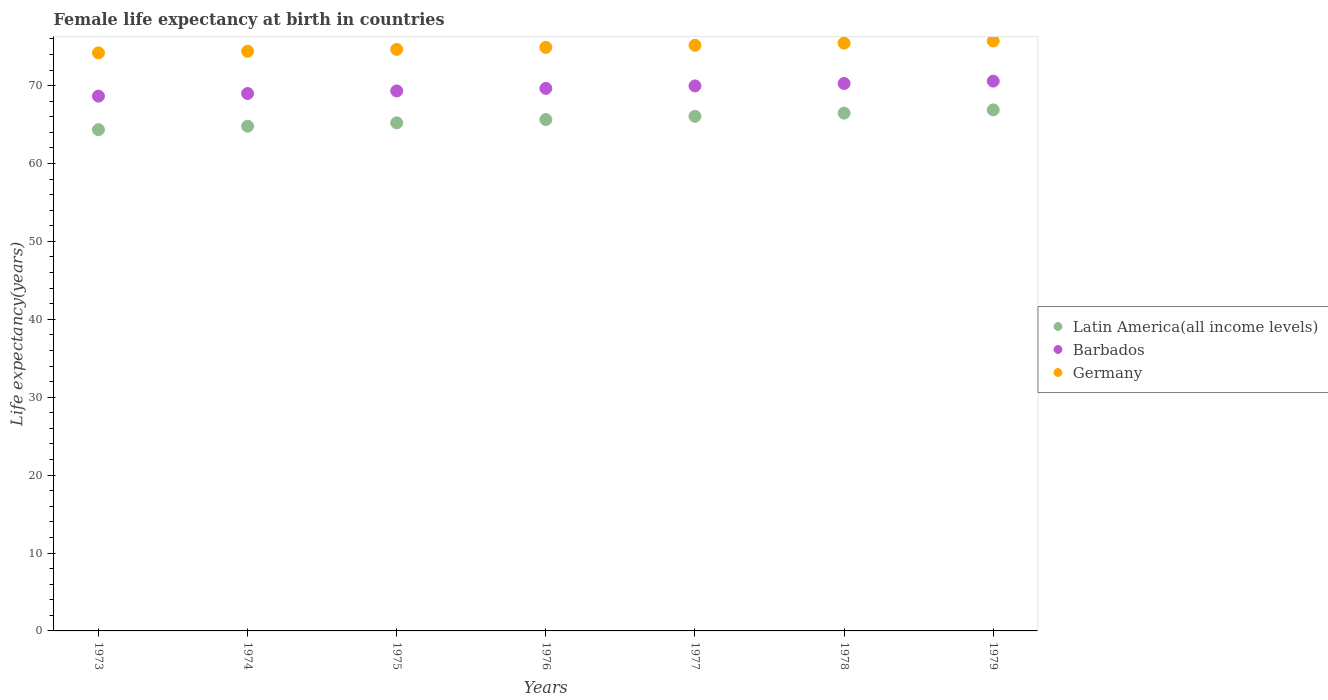What is the female life expectancy at birth in Latin America(all income levels) in 1977?
Your answer should be compact. 66.05. Across all years, what is the maximum female life expectancy at birth in Germany?
Provide a short and direct response. 75.72. Across all years, what is the minimum female life expectancy at birth in Latin America(all income levels)?
Provide a short and direct response. 64.34. In which year was the female life expectancy at birth in Barbados maximum?
Provide a succinct answer. 1979. In which year was the female life expectancy at birth in Germany minimum?
Ensure brevity in your answer.  1973. What is the total female life expectancy at birth in Barbados in the graph?
Ensure brevity in your answer.  487.4. What is the difference between the female life expectancy at birth in Latin America(all income levels) in 1976 and that in 1978?
Provide a short and direct response. -0.83. What is the difference between the female life expectancy at birth in Germany in 1978 and the female life expectancy at birth in Latin America(all income levels) in 1976?
Your answer should be compact. 9.81. What is the average female life expectancy at birth in Germany per year?
Your answer should be compact. 74.93. In the year 1973, what is the difference between the female life expectancy at birth in Germany and female life expectancy at birth in Latin America(all income levels)?
Keep it short and to the point. 9.86. What is the ratio of the female life expectancy at birth in Germany in 1977 to that in 1979?
Your response must be concise. 0.99. What is the difference between the highest and the second highest female life expectancy at birth in Barbados?
Your answer should be compact. 0.3. What is the difference between the highest and the lowest female life expectancy at birth in Barbados?
Offer a terse response. 1.92. Is the sum of the female life expectancy at birth in Barbados in 1974 and 1975 greater than the maximum female life expectancy at birth in Germany across all years?
Provide a succinct answer. Yes. Is it the case that in every year, the sum of the female life expectancy at birth in Germany and female life expectancy at birth in Barbados  is greater than the female life expectancy at birth in Latin America(all income levels)?
Ensure brevity in your answer.  Yes. Is the female life expectancy at birth in Germany strictly less than the female life expectancy at birth in Latin America(all income levels) over the years?
Give a very brief answer. No. What is the difference between two consecutive major ticks on the Y-axis?
Give a very brief answer. 10. Are the values on the major ticks of Y-axis written in scientific E-notation?
Your answer should be compact. No. Does the graph contain any zero values?
Provide a succinct answer. No. Does the graph contain grids?
Your answer should be very brief. No. How are the legend labels stacked?
Ensure brevity in your answer.  Vertical. What is the title of the graph?
Keep it short and to the point. Female life expectancy at birth in countries. What is the label or title of the Y-axis?
Your answer should be compact. Life expectancy(years). What is the Life expectancy(years) of Latin America(all income levels) in 1973?
Give a very brief answer. 64.34. What is the Life expectancy(years) of Barbados in 1973?
Provide a short and direct response. 68.65. What is the Life expectancy(years) of Germany in 1973?
Ensure brevity in your answer.  74.2. What is the Life expectancy(years) in Latin America(all income levels) in 1974?
Give a very brief answer. 64.79. What is the Life expectancy(years) in Barbados in 1974?
Provide a succinct answer. 68.99. What is the Life expectancy(years) in Germany in 1974?
Your answer should be very brief. 74.41. What is the Life expectancy(years) in Latin America(all income levels) in 1975?
Ensure brevity in your answer.  65.22. What is the Life expectancy(years) of Barbados in 1975?
Provide a succinct answer. 69.32. What is the Life expectancy(years) of Germany in 1975?
Your answer should be compact. 74.65. What is the Life expectancy(years) of Latin America(all income levels) in 1976?
Keep it short and to the point. 65.64. What is the Life expectancy(years) in Barbados in 1976?
Make the answer very short. 69.64. What is the Life expectancy(years) of Germany in 1976?
Ensure brevity in your answer.  74.9. What is the Life expectancy(years) in Latin America(all income levels) in 1977?
Your response must be concise. 66.05. What is the Life expectancy(years) in Barbados in 1977?
Your answer should be very brief. 69.96. What is the Life expectancy(years) of Germany in 1977?
Provide a succinct answer. 75.17. What is the Life expectancy(years) in Latin America(all income levels) in 1978?
Provide a short and direct response. 66.47. What is the Life expectancy(years) of Barbados in 1978?
Make the answer very short. 70.27. What is the Life expectancy(years) of Germany in 1978?
Your response must be concise. 75.45. What is the Life expectancy(years) of Latin America(all income levels) in 1979?
Your answer should be very brief. 66.89. What is the Life expectancy(years) of Barbados in 1979?
Keep it short and to the point. 70.58. What is the Life expectancy(years) in Germany in 1979?
Offer a very short reply. 75.72. Across all years, what is the maximum Life expectancy(years) of Latin America(all income levels)?
Ensure brevity in your answer.  66.89. Across all years, what is the maximum Life expectancy(years) of Barbados?
Keep it short and to the point. 70.58. Across all years, what is the maximum Life expectancy(years) in Germany?
Give a very brief answer. 75.72. Across all years, what is the minimum Life expectancy(years) in Latin America(all income levels)?
Your response must be concise. 64.34. Across all years, what is the minimum Life expectancy(years) in Barbados?
Provide a succinct answer. 68.65. Across all years, what is the minimum Life expectancy(years) of Germany?
Make the answer very short. 74.2. What is the total Life expectancy(years) in Latin America(all income levels) in the graph?
Your response must be concise. 459.4. What is the total Life expectancy(years) of Barbados in the graph?
Your answer should be compact. 487.4. What is the total Life expectancy(years) of Germany in the graph?
Your answer should be compact. 524.51. What is the difference between the Life expectancy(years) of Latin America(all income levels) in 1973 and that in 1974?
Make the answer very short. -0.45. What is the difference between the Life expectancy(years) in Barbados in 1973 and that in 1974?
Keep it short and to the point. -0.34. What is the difference between the Life expectancy(years) in Germany in 1973 and that in 1974?
Make the answer very short. -0.21. What is the difference between the Life expectancy(years) of Latin America(all income levels) in 1973 and that in 1975?
Your answer should be compact. -0.88. What is the difference between the Life expectancy(years) of Barbados in 1973 and that in 1975?
Keep it short and to the point. -0.67. What is the difference between the Life expectancy(years) in Germany in 1973 and that in 1975?
Offer a very short reply. -0.45. What is the difference between the Life expectancy(years) of Latin America(all income levels) in 1973 and that in 1976?
Provide a short and direct response. -1.3. What is the difference between the Life expectancy(years) of Barbados in 1973 and that in 1976?
Ensure brevity in your answer.  -0.99. What is the difference between the Life expectancy(years) of Germany in 1973 and that in 1976?
Give a very brief answer. -0.7. What is the difference between the Life expectancy(years) of Latin America(all income levels) in 1973 and that in 1977?
Give a very brief answer. -1.71. What is the difference between the Life expectancy(years) of Barbados in 1973 and that in 1977?
Keep it short and to the point. -1.31. What is the difference between the Life expectancy(years) of Germany in 1973 and that in 1977?
Provide a succinct answer. -0.97. What is the difference between the Life expectancy(years) of Latin America(all income levels) in 1973 and that in 1978?
Ensure brevity in your answer.  -2.13. What is the difference between the Life expectancy(years) of Barbados in 1973 and that in 1978?
Provide a short and direct response. -1.62. What is the difference between the Life expectancy(years) of Germany in 1973 and that in 1978?
Give a very brief answer. -1.25. What is the difference between the Life expectancy(years) of Latin America(all income levels) in 1973 and that in 1979?
Make the answer very short. -2.54. What is the difference between the Life expectancy(years) of Barbados in 1973 and that in 1979?
Offer a very short reply. -1.92. What is the difference between the Life expectancy(years) of Germany in 1973 and that in 1979?
Your response must be concise. -1.52. What is the difference between the Life expectancy(years) in Latin America(all income levels) in 1974 and that in 1975?
Give a very brief answer. -0.43. What is the difference between the Life expectancy(years) in Barbados in 1974 and that in 1975?
Ensure brevity in your answer.  -0.33. What is the difference between the Life expectancy(years) of Germany in 1974 and that in 1975?
Offer a terse response. -0.23. What is the difference between the Life expectancy(years) in Latin America(all income levels) in 1974 and that in 1976?
Your answer should be very brief. -0.85. What is the difference between the Life expectancy(years) in Barbados in 1974 and that in 1976?
Provide a succinct answer. -0.66. What is the difference between the Life expectancy(years) of Germany in 1974 and that in 1976?
Keep it short and to the point. -0.49. What is the difference between the Life expectancy(years) of Latin America(all income levels) in 1974 and that in 1977?
Your answer should be very brief. -1.27. What is the difference between the Life expectancy(years) in Barbados in 1974 and that in 1977?
Give a very brief answer. -0.97. What is the difference between the Life expectancy(years) in Germany in 1974 and that in 1977?
Your answer should be compact. -0.76. What is the difference between the Life expectancy(years) of Latin America(all income levels) in 1974 and that in 1978?
Give a very brief answer. -1.68. What is the difference between the Life expectancy(years) in Barbados in 1974 and that in 1978?
Your answer should be compact. -1.28. What is the difference between the Life expectancy(years) in Germany in 1974 and that in 1978?
Your answer should be compact. -1.04. What is the difference between the Life expectancy(years) in Latin America(all income levels) in 1974 and that in 1979?
Provide a succinct answer. -2.1. What is the difference between the Life expectancy(years) in Barbados in 1974 and that in 1979?
Keep it short and to the point. -1.59. What is the difference between the Life expectancy(years) of Germany in 1974 and that in 1979?
Offer a very short reply. -1.31. What is the difference between the Life expectancy(years) of Latin America(all income levels) in 1975 and that in 1976?
Give a very brief answer. -0.42. What is the difference between the Life expectancy(years) of Barbados in 1975 and that in 1976?
Keep it short and to the point. -0.33. What is the difference between the Life expectancy(years) of Germany in 1975 and that in 1976?
Your response must be concise. -0.26. What is the difference between the Life expectancy(years) in Latin America(all income levels) in 1975 and that in 1977?
Provide a succinct answer. -0.83. What is the difference between the Life expectancy(years) in Barbados in 1975 and that in 1977?
Your answer should be very brief. -0.64. What is the difference between the Life expectancy(years) of Germany in 1975 and that in 1977?
Offer a terse response. -0.53. What is the difference between the Life expectancy(years) in Latin America(all income levels) in 1975 and that in 1978?
Provide a short and direct response. -1.25. What is the difference between the Life expectancy(years) in Barbados in 1975 and that in 1978?
Ensure brevity in your answer.  -0.95. What is the difference between the Life expectancy(years) in Germany in 1975 and that in 1978?
Give a very brief answer. -0.8. What is the difference between the Life expectancy(years) of Latin America(all income levels) in 1975 and that in 1979?
Your answer should be compact. -1.67. What is the difference between the Life expectancy(years) of Barbados in 1975 and that in 1979?
Ensure brevity in your answer.  -1.26. What is the difference between the Life expectancy(years) of Germany in 1975 and that in 1979?
Make the answer very short. -1.08. What is the difference between the Life expectancy(years) in Latin America(all income levels) in 1976 and that in 1977?
Your answer should be compact. -0.41. What is the difference between the Life expectancy(years) in Barbados in 1976 and that in 1977?
Provide a short and direct response. -0.32. What is the difference between the Life expectancy(years) in Germany in 1976 and that in 1977?
Your response must be concise. -0.27. What is the difference between the Life expectancy(years) in Latin America(all income levels) in 1976 and that in 1978?
Your answer should be compact. -0.83. What is the difference between the Life expectancy(years) of Barbados in 1976 and that in 1978?
Keep it short and to the point. -0.63. What is the difference between the Life expectancy(years) in Germany in 1976 and that in 1978?
Offer a terse response. -0.54. What is the difference between the Life expectancy(years) in Latin America(all income levels) in 1976 and that in 1979?
Offer a very short reply. -1.25. What is the difference between the Life expectancy(years) of Barbados in 1976 and that in 1979?
Provide a succinct answer. -0.93. What is the difference between the Life expectancy(years) of Germany in 1976 and that in 1979?
Give a very brief answer. -0.82. What is the difference between the Life expectancy(years) in Latin America(all income levels) in 1977 and that in 1978?
Your answer should be very brief. -0.42. What is the difference between the Life expectancy(years) in Barbados in 1977 and that in 1978?
Offer a very short reply. -0.31. What is the difference between the Life expectancy(years) of Germany in 1977 and that in 1978?
Keep it short and to the point. -0.28. What is the difference between the Life expectancy(years) in Latin America(all income levels) in 1977 and that in 1979?
Provide a short and direct response. -0.83. What is the difference between the Life expectancy(years) of Barbados in 1977 and that in 1979?
Offer a very short reply. -0.61. What is the difference between the Life expectancy(years) of Germany in 1977 and that in 1979?
Your answer should be compact. -0.55. What is the difference between the Life expectancy(years) in Latin America(all income levels) in 1978 and that in 1979?
Offer a terse response. -0.42. What is the difference between the Life expectancy(years) of Barbados in 1978 and that in 1979?
Provide a succinct answer. -0.3. What is the difference between the Life expectancy(years) of Germany in 1978 and that in 1979?
Give a very brief answer. -0.28. What is the difference between the Life expectancy(years) in Latin America(all income levels) in 1973 and the Life expectancy(years) in Barbados in 1974?
Offer a terse response. -4.64. What is the difference between the Life expectancy(years) of Latin America(all income levels) in 1973 and the Life expectancy(years) of Germany in 1974?
Provide a short and direct response. -10.07. What is the difference between the Life expectancy(years) in Barbados in 1973 and the Life expectancy(years) in Germany in 1974?
Your answer should be very brief. -5.76. What is the difference between the Life expectancy(years) of Latin America(all income levels) in 1973 and the Life expectancy(years) of Barbados in 1975?
Keep it short and to the point. -4.97. What is the difference between the Life expectancy(years) in Latin America(all income levels) in 1973 and the Life expectancy(years) in Germany in 1975?
Offer a very short reply. -10.3. What is the difference between the Life expectancy(years) in Barbados in 1973 and the Life expectancy(years) in Germany in 1975?
Make the answer very short. -6. What is the difference between the Life expectancy(years) in Latin America(all income levels) in 1973 and the Life expectancy(years) in Barbados in 1976?
Your response must be concise. -5.3. What is the difference between the Life expectancy(years) of Latin America(all income levels) in 1973 and the Life expectancy(years) of Germany in 1976?
Give a very brief answer. -10.56. What is the difference between the Life expectancy(years) of Barbados in 1973 and the Life expectancy(years) of Germany in 1976?
Offer a very short reply. -6.25. What is the difference between the Life expectancy(years) in Latin America(all income levels) in 1973 and the Life expectancy(years) in Barbados in 1977?
Offer a very short reply. -5.62. What is the difference between the Life expectancy(years) of Latin America(all income levels) in 1973 and the Life expectancy(years) of Germany in 1977?
Give a very brief answer. -10.83. What is the difference between the Life expectancy(years) of Barbados in 1973 and the Life expectancy(years) of Germany in 1977?
Keep it short and to the point. -6.52. What is the difference between the Life expectancy(years) in Latin America(all income levels) in 1973 and the Life expectancy(years) in Barbados in 1978?
Your answer should be compact. -5.93. What is the difference between the Life expectancy(years) in Latin America(all income levels) in 1973 and the Life expectancy(years) in Germany in 1978?
Make the answer very short. -11.11. What is the difference between the Life expectancy(years) in Barbados in 1973 and the Life expectancy(years) in Germany in 1978?
Make the answer very short. -6.8. What is the difference between the Life expectancy(years) of Latin America(all income levels) in 1973 and the Life expectancy(years) of Barbados in 1979?
Your response must be concise. -6.23. What is the difference between the Life expectancy(years) of Latin America(all income levels) in 1973 and the Life expectancy(years) of Germany in 1979?
Give a very brief answer. -11.38. What is the difference between the Life expectancy(years) of Barbados in 1973 and the Life expectancy(years) of Germany in 1979?
Provide a succinct answer. -7.07. What is the difference between the Life expectancy(years) of Latin America(all income levels) in 1974 and the Life expectancy(years) of Barbados in 1975?
Your response must be concise. -4.53. What is the difference between the Life expectancy(years) of Latin America(all income levels) in 1974 and the Life expectancy(years) of Germany in 1975?
Offer a terse response. -9.86. What is the difference between the Life expectancy(years) in Barbados in 1974 and the Life expectancy(years) in Germany in 1975?
Ensure brevity in your answer.  -5.66. What is the difference between the Life expectancy(years) of Latin America(all income levels) in 1974 and the Life expectancy(years) of Barbados in 1976?
Ensure brevity in your answer.  -4.85. What is the difference between the Life expectancy(years) of Latin America(all income levels) in 1974 and the Life expectancy(years) of Germany in 1976?
Provide a succinct answer. -10.12. What is the difference between the Life expectancy(years) of Barbados in 1974 and the Life expectancy(years) of Germany in 1976?
Ensure brevity in your answer.  -5.92. What is the difference between the Life expectancy(years) in Latin America(all income levels) in 1974 and the Life expectancy(years) in Barbados in 1977?
Offer a very short reply. -5.17. What is the difference between the Life expectancy(years) of Latin America(all income levels) in 1974 and the Life expectancy(years) of Germany in 1977?
Offer a terse response. -10.38. What is the difference between the Life expectancy(years) in Barbados in 1974 and the Life expectancy(years) in Germany in 1977?
Your answer should be compact. -6.19. What is the difference between the Life expectancy(years) in Latin America(all income levels) in 1974 and the Life expectancy(years) in Barbados in 1978?
Provide a succinct answer. -5.48. What is the difference between the Life expectancy(years) in Latin America(all income levels) in 1974 and the Life expectancy(years) in Germany in 1978?
Provide a short and direct response. -10.66. What is the difference between the Life expectancy(years) in Barbados in 1974 and the Life expectancy(years) in Germany in 1978?
Ensure brevity in your answer.  -6.46. What is the difference between the Life expectancy(years) in Latin America(all income levels) in 1974 and the Life expectancy(years) in Barbados in 1979?
Make the answer very short. -5.79. What is the difference between the Life expectancy(years) of Latin America(all income levels) in 1974 and the Life expectancy(years) of Germany in 1979?
Your answer should be compact. -10.94. What is the difference between the Life expectancy(years) in Barbados in 1974 and the Life expectancy(years) in Germany in 1979?
Ensure brevity in your answer.  -6.74. What is the difference between the Life expectancy(years) in Latin America(all income levels) in 1975 and the Life expectancy(years) in Barbados in 1976?
Keep it short and to the point. -4.42. What is the difference between the Life expectancy(years) in Latin America(all income levels) in 1975 and the Life expectancy(years) in Germany in 1976?
Offer a very short reply. -9.68. What is the difference between the Life expectancy(years) of Barbados in 1975 and the Life expectancy(years) of Germany in 1976?
Offer a terse response. -5.59. What is the difference between the Life expectancy(years) of Latin America(all income levels) in 1975 and the Life expectancy(years) of Barbados in 1977?
Ensure brevity in your answer.  -4.74. What is the difference between the Life expectancy(years) in Latin America(all income levels) in 1975 and the Life expectancy(years) in Germany in 1977?
Provide a short and direct response. -9.95. What is the difference between the Life expectancy(years) in Barbados in 1975 and the Life expectancy(years) in Germany in 1977?
Give a very brief answer. -5.86. What is the difference between the Life expectancy(years) in Latin America(all income levels) in 1975 and the Life expectancy(years) in Barbados in 1978?
Offer a terse response. -5.05. What is the difference between the Life expectancy(years) of Latin America(all income levels) in 1975 and the Life expectancy(years) of Germany in 1978?
Your response must be concise. -10.23. What is the difference between the Life expectancy(years) of Barbados in 1975 and the Life expectancy(years) of Germany in 1978?
Ensure brevity in your answer.  -6.13. What is the difference between the Life expectancy(years) of Latin America(all income levels) in 1975 and the Life expectancy(years) of Barbados in 1979?
Offer a terse response. -5.36. What is the difference between the Life expectancy(years) in Latin America(all income levels) in 1975 and the Life expectancy(years) in Germany in 1979?
Your answer should be compact. -10.51. What is the difference between the Life expectancy(years) in Barbados in 1975 and the Life expectancy(years) in Germany in 1979?
Give a very brief answer. -6.41. What is the difference between the Life expectancy(years) of Latin America(all income levels) in 1976 and the Life expectancy(years) of Barbados in 1977?
Ensure brevity in your answer.  -4.32. What is the difference between the Life expectancy(years) of Latin America(all income levels) in 1976 and the Life expectancy(years) of Germany in 1977?
Your answer should be very brief. -9.53. What is the difference between the Life expectancy(years) in Barbados in 1976 and the Life expectancy(years) in Germany in 1977?
Provide a short and direct response. -5.53. What is the difference between the Life expectancy(years) of Latin America(all income levels) in 1976 and the Life expectancy(years) of Barbados in 1978?
Offer a very short reply. -4.63. What is the difference between the Life expectancy(years) of Latin America(all income levels) in 1976 and the Life expectancy(years) of Germany in 1978?
Keep it short and to the point. -9.81. What is the difference between the Life expectancy(years) in Barbados in 1976 and the Life expectancy(years) in Germany in 1978?
Your answer should be compact. -5.81. What is the difference between the Life expectancy(years) in Latin America(all income levels) in 1976 and the Life expectancy(years) in Barbados in 1979?
Offer a very short reply. -4.94. What is the difference between the Life expectancy(years) of Latin America(all income levels) in 1976 and the Life expectancy(years) of Germany in 1979?
Offer a very short reply. -10.09. What is the difference between the Life expectancy(years) in Barbados in 1976 and the Life expectancy(years) in Germany in 1979?
Your answer should be compact. -6.08. What is the difference between the Life expectancy(years) in Latin America(all income levels) in 1977 and the Life expectancy(years) in Barbados in 1978?
Offer a terse response. -4.22. What is the difference between the Life expectancy(years) of Latin America(all income levels) in 1977 and the Life expectancy(years) of Germany in 1978?
Ensure brevity in your answer.  -9.39. What is the difference between the Life expectancy(years) of Barbados in 1977 and the Life expectancy(years) of Germany in 1978?
Provide a short and direct response. -5.49. What is the difference between the Life expectancy(years) in Latin America(all income levels) in 1977 and the Life expectancy(years) in Barbados in 1979?
Your response must be concise. -4.52. What is the difference between the Life expectancy(years) in Latin America(all income levels) in 1977 and the Life expectancy(years) in Germany in 1979?
Offer a very short reply. -9.67. What is the difference between the Life expectancy(years) of Barbados in 1977 and the Life expectancy(years) of Germany in 1979?
Give a very brief answer. -5.76. What is the difference between the Life expectancy(years) of Latin America(all income levels) in 1978 and the Life expectancy(years) of Barbados in 1979?
Provide a succinct answer. -4.11. What is the difference between the Life expectancy(years) of Latin America(all income levels) in 1978 and the Life expectancy(years) of Germany in 1979?
Make the answer very short. -9.26. What is the difference between the Life expectancy(years) in Barbados in 1978 and the Life expectancy(years) in Germany in 1979?
Offer a very short reply. -5.45. What is the average Life expectancy(years) in Latin America(all income levels) per year?
Make the answer very short. 65.63. What is the average Life expectancy(years) in Barbados per year?
Your answer should be very brief. 69.63. What is the average Life expectancy(years) in Germany per year?
Ensure brevity in your answer.  74.93. In the year 1973, what is the difference between the Life expectancy(years) in Latin America(all income levels) and Life expectancy(years) in Barbados?
Your answer should be compact. -4.31. In the year 1973, what is the difference between the Life expectancy(years) of Latin America(all income levels) and Life expectancy(years) of Germany?
Your answer should be compact. -9.86. In the year 1973, what is the difference between the Life expectancy(years) in Barbados and Life expectancy(years) in Germany?
Give a very brief answer. -5.55. In the year 1974, what is the difference between the Life expectancy(years) in Latin America(all income levels) and Life expectancy(years) in Barbados?
Make the answer very short. -4.2. In the year 1974, what is the difference between the Life expectancy(years) of Latin America(all income levels) and Life expectancy(years) of Germany?
Offer a terse response. -9.62. In the year 1974, what is the difference between the Life expectancy(years) in Barbados and Life expectancy(years) in Germany?
Ensure brevity in your answer.  -5.42. In the year 1975, what is the difference between the Life expectancy(years) of Latin America(all income levels) and Life expectancy(years) of Barbados?
Make the answer very short. -4.1. In the year 1975, what is the difference between the Life expectancy(years) in Latin America(all income levels) and Life expectancy(years) in Germany?
Provide a short and direct response. -9.43. In the year 1975, what is the difference between the Life expectancy(years) of Barbados and Life expectancy(years) of Germany?
Your response must be concise. -5.33. In the year 1976, what is the difference between the Life expectancy(years) in Latin America(all income levels) and Life expectancy(years) in Barbados?
Your answer should be very brief. -4. In the year 1976, what is the difference between the Life expectancy(years) of Latin America(all income levels) and Life expectancy(years) of Germany?
Your response must be concise. -9.26. In the year 1976, what is the difference between the Life expectancy(years) in Barbados and Life expectancy(years) in Germany?
Your answer should be compact. -5.26. In the year 1977, what is the difference between the Life expectancy(years) of Latin America(all income levels) and Life expectancy(years) of Barbados?
Your answer should be compact. -3.91. In the year 1977, what is the difference between the Life expectancy(years) in Latin America(all income levels) and Life expectancy(years) in Germany?
Make the answer very short. -9.12. In the year 1977, what is the difference between the Life expectancy(years) of Barbados and Life expectancy(years) of Germany?
Provide a short and direct response. -5.21. In the year 1978, what is the difference between the Life expectancy(years) of Latin America(all income levels) and Life expectancy(years) of Barbados?
Keep it short and to the point. -3.8. In the year 1978, what is the difference between the Life expectancy(years) in Latin America(all income levels) and Life expectancy(years) in Germany?
Offer a very short reply. -8.98. In the year 1978, what is the difference between the Life expectancy(years) of Barbados and Life expectancy(years) of Germany?
Your response must be concise. -5.18. In the year 1979, what is the difference between the Life expectancy(years) in Latin America(all income levels) and Life expectancy(years) in Barbados?
Offer a very short reply. -3.69. In the year 1979, what is the difference between the Life expectancy(years) of Latin America(all income levels) and Life expectancy(years) of Germany?
Provide a short and direct response. -8.84. In the year 1979, what is the difference between the Life expectancy(years) in Barbados and Life expectancy(years) in Germany?
Your answer should be compact. -5.15. What is the ratio of the Life expectancy(years) in Germany in 1973 to that in 1974?
Give a very brief answer. 1. What is the ratio of the Life expectancy(years) of Latin America(all income levels) in 1973 to that in 1975?
Provide a succinct answer. 0.99. What is the ratio of the Life expectancy(years) of Barbados in 1973 to that in 1975?
Offer a terse response. 0.99. What is the ratio of the Life expectancy(years) of Germany in 1973 to that in 1975?
Provide a succinct answer. 0.99. What is the ratio of the Life expectancy(years) in Latin America(all income levels) in 1973 to that in 1976?
Give a very brief answer. 0.98. What is the ratio of the Life expectancy(years) in Barbados in 1973 to that in 1976?
Make the answer very short. 0.99. What is the ratio of the Life expectancy(years) of Germany in 1973 to that in 1976?
Offer a terse response. 0.99. What is the ratio of the Life expectancy(years) of Latin America(all income levels) in 1973 to that in 1977?
Offer a very short reply. 0.97. What is the ratio of the Life expectancy(years) of Barbados in 1973 to that in 1977?
Make the answer very short. 0.98. What is the ratio of the Life expectancy(years) of Germany in 1973 to that in 1977?
Offer a terse response. 0.99. What is the ratio of the Life expectancy(years) in Latin America(all income levels) in 1973 to that in 1978?
Make the answer very short. 0.97. What is the ratio of the Life expectancy(years) in Barbados in 1973 to that in 1978?
Make the answer very short. 0.98. What is the ratio of the Life expectancy(years) of Germany in 1973 to that in 1978?
Your answer should be compact. 0.98. What is the ratio of the Life expectancy(years) in Barbados in 1973 to that in 1979?
Keep it short and to the point. 0.97. What is the ratio of the Life expectancy(years) of Germany in 1973 to that in 1979?
Offer a terse response. 0.98. What is the ratio of the Life expectancy(years) of Latin America(all income levels) in 1974 to that in 1976?
Make the answer very short. 0.99. What is the ratio of the Life expectancy(years) of Barbados in 1974 to that in 1976?
Keep it short and to the point. 0.99. What is the ratio of the Life expectancy(years) of Latin America(all income levels) in 1974 to that in 1977?
Offer a terse response. 0.98. What is the ratio of the Life expectancy(years) of Barbados in 1974 to that in 1977?
Your answer should be very brief. 0.99. What is the ratio of the Life expectancy(years) in Germany in 1974 to that in 1977?
Ensure brevity in your answer.  0.99. What is the ratio of the Life expectancy(years) in Latin America(all income levels) in 1974 to that in 1978?
Keep it short and to the point. 0.97. What is the ratio of the Life expectancy(years) in Barbados in 1974 to that in 1978?
Your answer should be very brief. 0.98. What is the ratio of the Life expectancy(years) of Germany in 1974 to that in 1978?
Ensure brevity in your answer.  0.99. What is the ratio of the Life expectancy(years) in Latin America(all income levels) in 1974 to that in 1979?
Ensure brevity in your answer.  0.97. What is the ratio of the Life expectancy(years) of Barbados in 1974 to that in 1979?
Offer a terse response. 0.98. What is the ratio of the Life expectancy(years) in Germany in 1974 to that in 1979?
Ensure brevity in your answer.  0.98. What is the ratio of the Life expectancy(years) in Barbados in 1975 to that in 1976?
Your answer should be compact. 1. What is the ratio of the Life expectancy(years) in Germany in 1975 to that in 1976?
Your response must be concise. 1. What is the ratio of the Life expectancy(years) of Latin America(all income levels) in 1975 to that in 1977?
Make the answer very short. 0.99. What is the ratio of the Life expectancy(years) in Barbados in 1975 to that in 1977?
Make the answer very short. 0.99. What is the ratio of the Life expectancy(years) in Latin America(all income levels) in 1975 to that in 1978?
Your response must be concise. 0.98. What is the ratio of the Life expectancy(years) of Barbados in 1975 to that in 1978?
Give a very brief answer. 0.99. What is the ratio of the Life expectancy(years) of Germany in 1975 to that in 1978?
Keep it short and to the point. 0.99. What is the ratio of the Life expectancy(years) of Latin America(all income levels) in 1975 to that in 1979?
Offer a terse response. 0.98. What is the ratio of the Life expectancy(years) of Barbados in 1975 to that in 1979?
Keep it short and to the point. 0.98. What is the ratio of the Life expectancy(years) of Germany in 1975 to that in 1979?
Your response must be concise. 0.99. What is the ratio of the Life expectancy(years) of Latin America(all income levels) in 1976 to that in 1977?
Provide a short and direct response. 0.99. What is the ratio of the Life expectancy(years) of Barbados in 1976 to that in 1977?
Make the answer very short. 1. What is the ratio of the Life expectancy(years) of Germany in 1976 to that in 1977?
Your answer should be very brief. 1. What is the ratio of the Life expectancy(years) in Latin America(all income levels) in 1976 to that in 1978?
Keep it short and to the point. 0.99. What is the ratio of the Life expectancy(years) of Latin America(all income levels) in 1976 to that in 1979?
Provide a succinct answer. 0.98. What is the ratio of the Life expectancy(years) of Barbados in 1976 to that in 1979?
Offer a terse response. 0.99. What is the ratio of the Life expectancy(years) of Latin America(all income levels) in 1977 to that in 1978?
Make the answer very short. 0.99. What is the ratio of the Life expectancy(years) in Barbados in 1977 to that in 1978?
Offer a terse response. 1. What is the ratio of the Life expectancy(years) in Latin America(all income levels) in 1977 to that in 1979?
Give a very brief answer. 0.99. What is the ratio of the Life expectancy(years) of Barbados in 1977 to that in 1979?
Provide a succinct answer. 0.99. What is the ratio of the Life expectancy(years) in Germany in 1977 to that in 1979?
Make the answer very short. 0.99. What is the ratio of the Life expectancy(years) of Latin America(all income levels) in 1978 to that in 1979?
Your answer should be very brief. 0.99. What is the difference between the highest and the second highest Life expectancy(years) of Latin America(all income levels)?
Your answer should be compact. 0.42. What is the difference between the highest and the second highest Life expectancy(years) of Barbados?
Your answer should be compact. 0.3. What is the difference between the highest and the second highest Life expectancy(years) in Germany?
Offer a terse response. 0.28. What is the difference between the highest and the lowest Life expectancy(years) in Latin America(all income levels)?
Make the answer very short. 2.54. What is the difference between the highest and the lowest Life expectancy(years) of Barbados?
Offer a terse response. 1.92. What is the difference between the highest and the lowest Life expectancy(years) in Germany?
Make the answer very short. 1.52. 